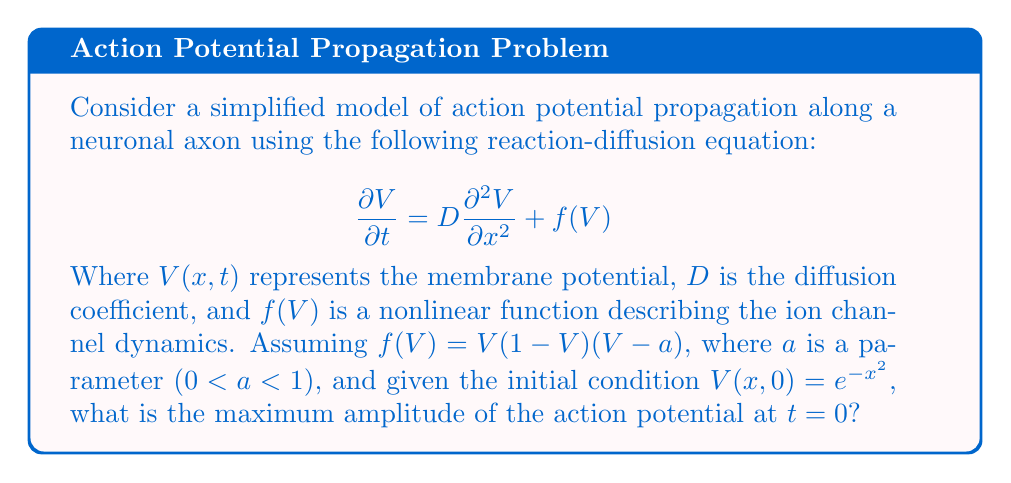Solve this math problem. To solve this problem, we need to follow these steps:

1) First, note that we're looking for the maximum amplitude at $t = 0$. This means we only need to consider the initial condition:

   $V(x,0) = e^{-x^2}$

2) The maximum of this function occurs where its derivative is zero:

   $\frac{d}{dx}(e^{-x^2}) = -2xe^{-x^2} = 0$

3) Solving this equation:
   $-2xe^{-x^2} = 0$
   This is true when $x = 0$ (since $e^{-x^2}$ is never zero for real $x$)

4) Therefore, the maximum occurs at $x = 0$

5) The value of the function at this point is:

   $V(0,0) = e^{-(0)^2} = e^0 = 1$

Thus, the maximum amplitude of the action potential at $t = 0$ is 1.

Note: While the reaction-diffusion equation describes the evolution of the system over time, the initial condition alone determines the maximum amplitude at $t = 0$. The dynamics of how this initial condition evolves according to the equation would be relevant for $t > 0$.
Answer: 1 